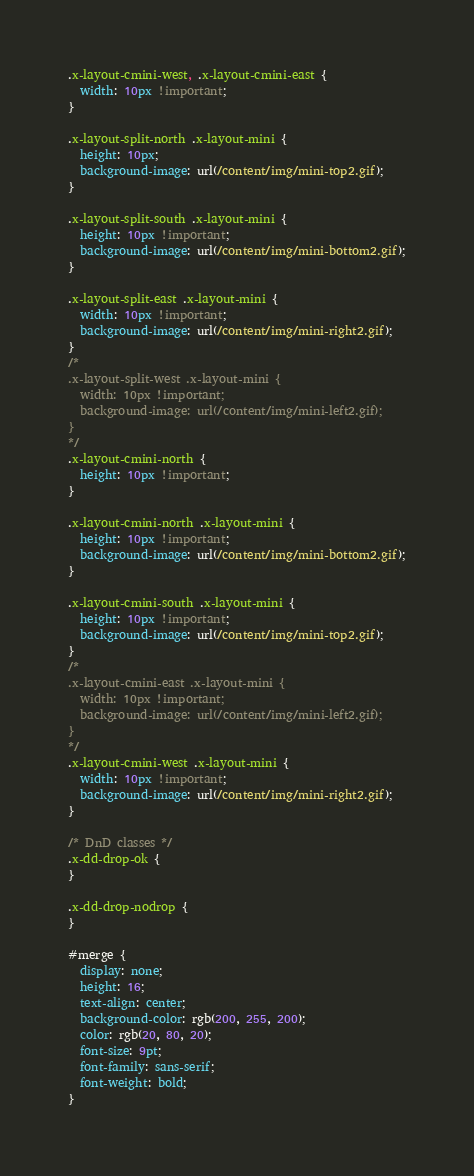<code> <loc_0><loc_0><loc_500><loc_500><_CSS_>.x-layout-cmini-west, .x-layout-cmini-east {
  width: 10px !important;
}

.x-layout-split-north .x-layout-mini {
  height: 10px;
  background-image: url(/content/img/mini-top2.gif);
}

.x-layout-split-south .x-layout-mini {
  height: 10px !important;
  background-image: url(/content/img/mini-bottom2.gif);
}

.x-layout-split-east .x-layout-mini {
  width: 10px !important;
  background-image: url(/content/img/mini-right2.gif);
}
/*
.x-layout-split-west .x-layout-mini {
  width: 10px !important;
  background-image: url(/content/img/mini-left2.gif);
}
*/
.x-layout-cmini-north {
  height: 10px !important;
}

.x-layout-cmini-north .x-layout-mini {
  height: 10px !important;
  background-image: url(/content/img/mini-bottom2.gif);
}

.x-layout-cmini-south .x-layout-mini {
  height: 10px !important;
  background-image: url(/content/img/mini-top2.gif);
}
/*
.x-layout-cmini-east .x-layout-mini {
  width: 10px !important;
  background-image: url(/content/img/mini-left2.gif);
}
*/
.x-layout-cmini-west .x-layout-mini {
  width: 10px !important;
  background-image: url(/content/img/mini-right2.gif);
}

/* DnD classes */
.x-dd-drop-ok {
}

.x-dd-drop-nodrop {
}

#merge {
  display: none;
  height: 16;
  text-align: center;
  background-color: rgb(200, 255, 200);
  color: rgb(20, 80, 20);
  font-size: 9pt;
  font-family: sans-serif;
  font-weight: bold;
}
</code> 